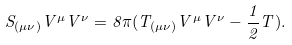<formula> <loc_0><loc_0><loc_500><loc_500>S _ { ( \mu \nu ) } V ^ { \mu } V ^ { \nu } = 8 \pi ( T _ { ( \mu \nu ) } V ^ { \mu } V ^ { \nu } - \frac { 1 } { 2 } T ) .</formula> 